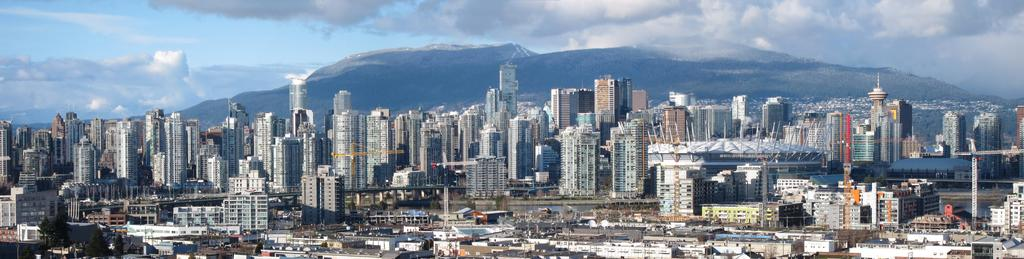What type of structures can be seen in the image? There are buildings in the image. What natural elements are present in the image? There are trees and mountains in the image. What type of machinery can be seen in the image? There are cranes in the image. What body of water is visible in the image? There is water visible in the image. What is visible in the sky at the top of the image? There are clouds in the sky at the top of the image. What type of punishment is being carried out on the dinosaurs in the image? There are no dinosaurs present in the image, so there is no punishment being carried out on them. What is the interest rate for the loan depicted in the image? There is no loan or interest rate mentioned or depicted in the image. 